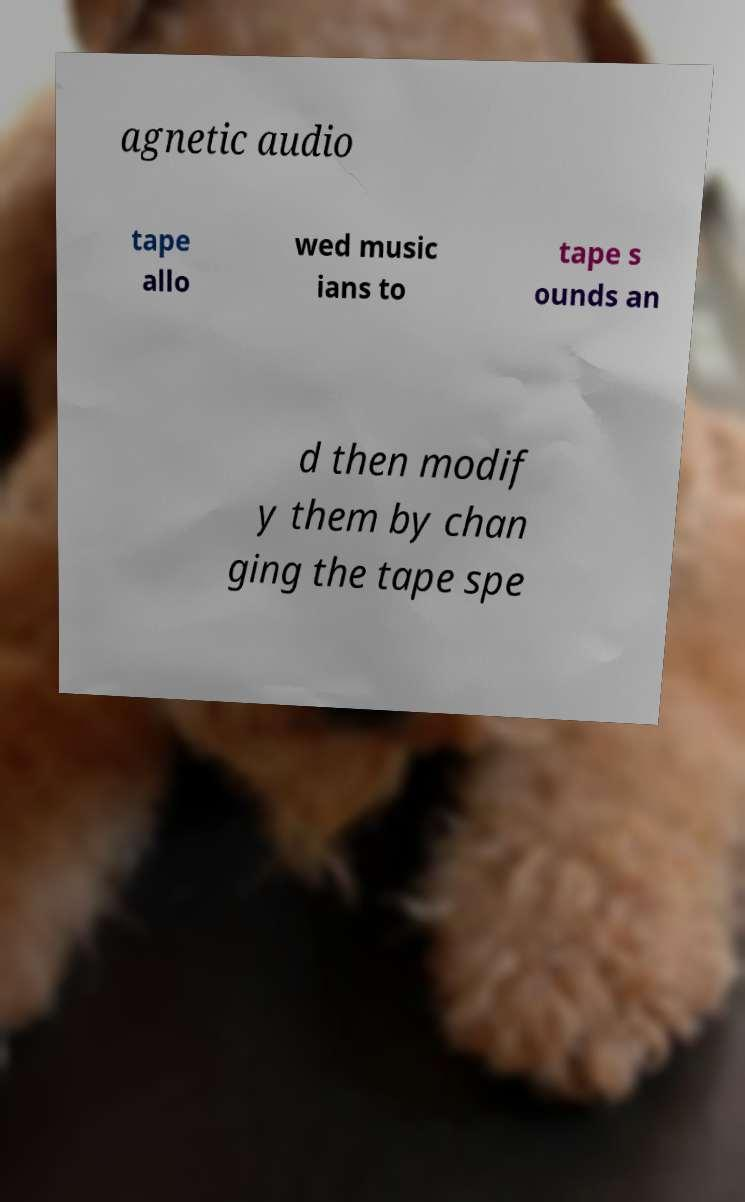Can you read and provide the text displayed in the image?This photo seems to have some interesting text. Can you extract and type it out for me? agnetic audio tape allo wed music ians to tape s ounds an d then modif y them by chan ging the tape spe 